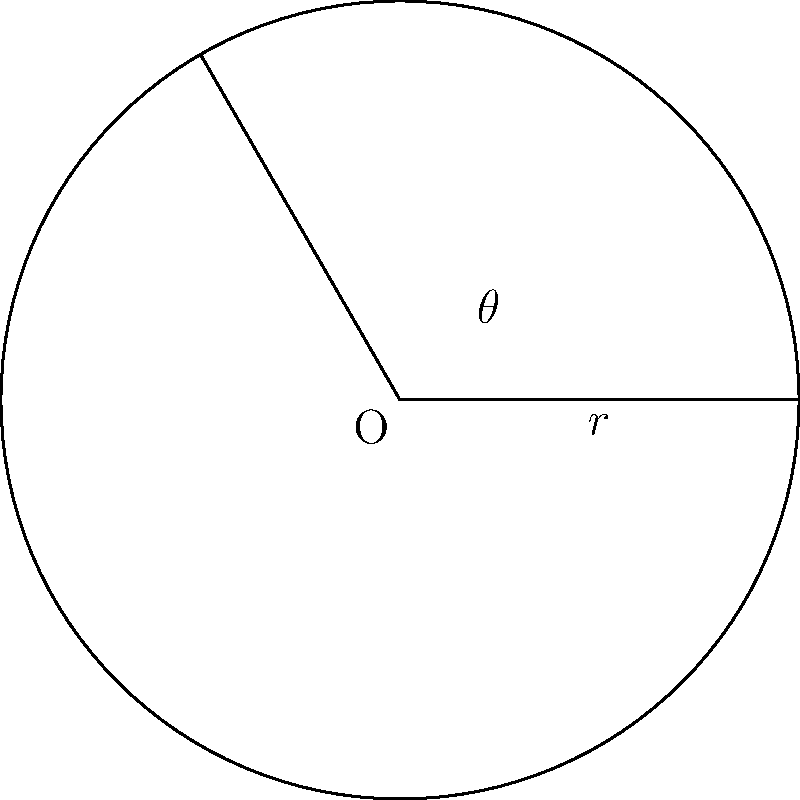In a game of bridge, you're discussing circle geometry with your partner during a break. You draw a sector of a circle with radius $r = 5$ cm and central angle $\theta = 120°$. What is the area of this sector? Let's approach this step-by-step:

1) The formula for the area of a sector is:

   $$A = \frac{\theta}{360°} \cdot \pi r^2$$

   Where $\theta$ is in degrees, $r$ is the radius, and $A$ is the area.

2) We're given:
   $r = 5$ cm
   $\theta = 120°$

3) Let's substitute these values into our formula:

   $$A = \frac{120°}{360°} \cdot \pi (5\text{ cm})^2$$

4) Simplify the fraction:

   $$A = \frac{1}{3} \cdot \pi (25\text{ cm}^2)$$

5) Multiply:

   $$A = \frac{25\pi}{3} \text{ cm}^2$$

6) If we want to calculate the exact value:

   $$A \approx 26.18 \text{ cm}^2$$ (rounded to two decimal places)
Answer: $\frac{25\pi}{3} \text{ cm}^2$ or approximately $26.18 \text{ cm}^2$ 